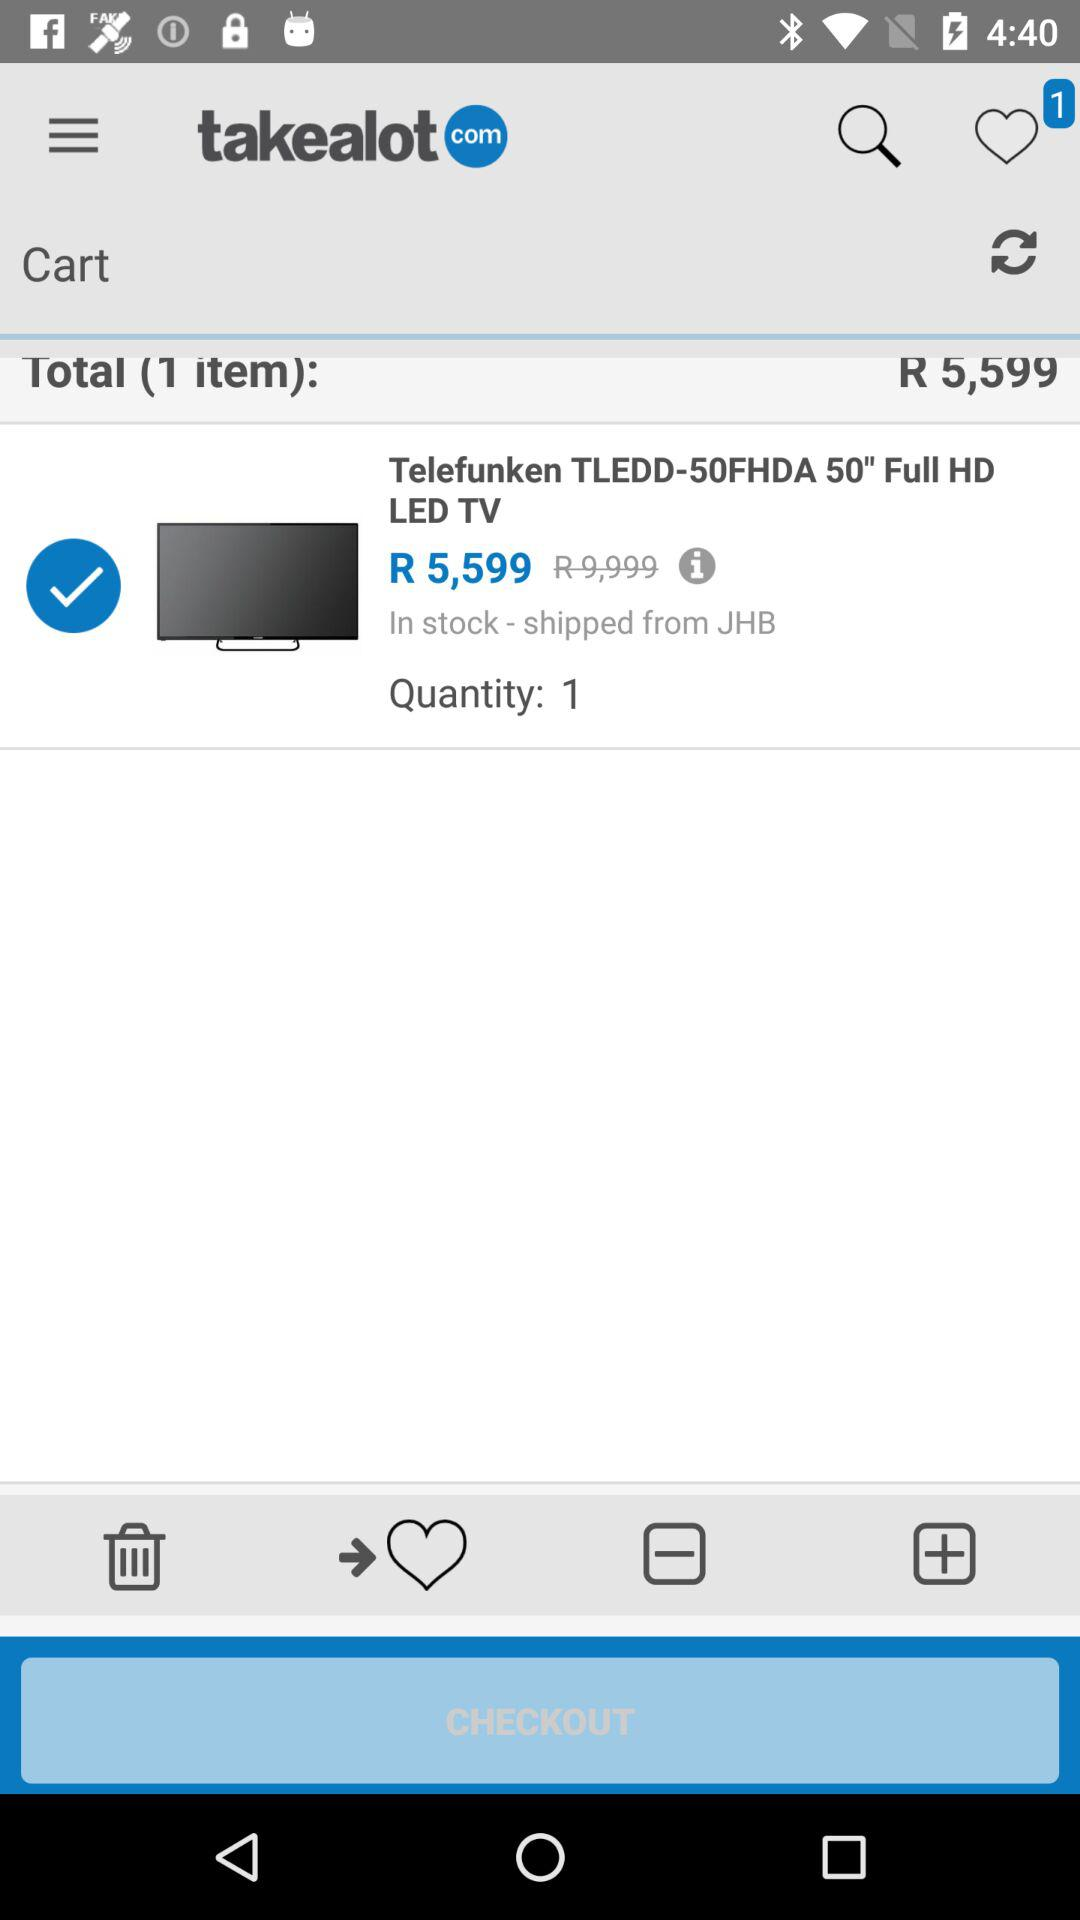How many favorites are there? There is 1 favorite. 